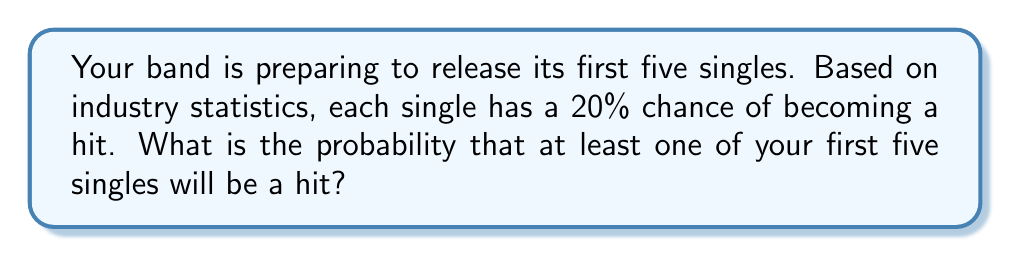What is the answer to this math problem? Let's approach this step-by-step:

1) First, let's define our events:
   Let A be the event "at least one of the first five singles is a hit"

2) It's often easier to calculate the probability of the complement event:
   P(A) = 1 - P(not A)
   Where "not A" is the event that none of the singles are hits

3) For a single to not be a hit, its probability is:
   P(not hit) = 1 - P(hit) = 1 - 0.20 = 0.80

4) For all five singles to not be hits, we multiply these probabilities:
   P(not A) = $0.80^5$

5) Now we can calculate P(A):
   P(A) = 1 - P(not A)
        = $1 - 0.80^5$
        = $1 - 0.32768$
        = $0.67232$

6) Converting to a percentage:
   $0.67232 \times 100\% = 67.232\%$

Therefore, the probability of having at least one hit among your first five singles is approximately 67.23%.
Answer: 67.23% 